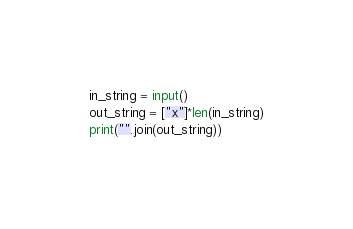Convert code to text. <code><loc_0><loc_0><loc_500><loc_500><_Python_>in_string = input()
out_string = ["x"]*len(in_string)
print("".join(out_string))</code> 